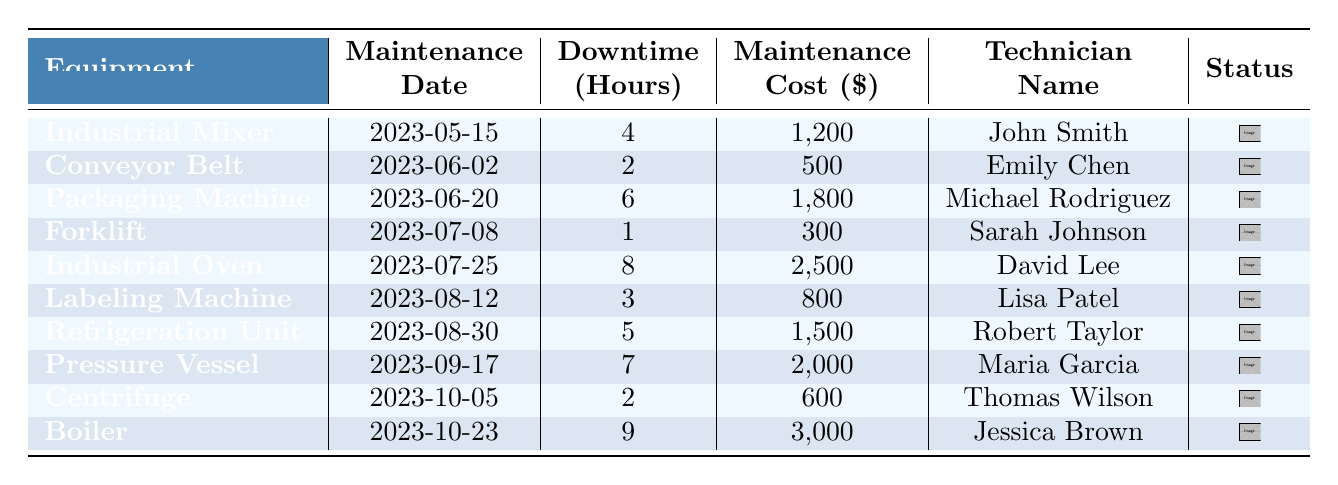What's the total downtime hours for all equipment? To find the total downtime hours, we sum the downtime for all equipment: 4 + 2 + 6 + 1 + 8 + 3 + 5 + 7 + 2 + 9 = 47 hours.
Answer: 47 Which piece of equipment had the highest maintenance cost? The maintenance costs for each piece of equipment are compared, and the highest cost is $3,000 for the Boiler.
Answer: Boiler What is the average downtime in hours per maintenance? The total downtime hours is 47 and there are 10 maintenance records. To find the average, divide 47 by 10: 47 / 10 = 4.7 hours.
Answer: 4.7 Did the Conveyor Belt have more downtime than the Labeling Machine? The Conveyor Belt had 2 hours of downtime and the Labeling Machine had 3 hours. Since 2 is less than 3, this statement is false.
Answer: No How many technicians had maintenance costs less than $1,500? We analyze the maintenance costs and find that the technicians associated with costs below $1,500 are Emily Chen ($500), Sarah Johnson ($300), Lisa Patel ($800), and Thomas Wilson ($600). This totals 4 technicians.
Answer: 4 What is the difference in downtime hours between the Industrial Oven and the Forklift? The Industrial Oven had 8 hours of downtime while the Forklift had 1 hour. The difference is 8 - 1 = 7 hours.
Answer: 7 Which technician performed maintenance on the Industrial Mixer? The table shows that John Smith was the technician who performed maintenance on the Industrial Mixer.
Answer: John Smith List all pieces of equipment that had a downtime of more than 5 hours. By examining the downtime hours, the pieces of equipment with more than 5 hours are the Packaging Machine (6), Industrial Oven (8), Refrigeration Unit (5), Pressure Vessel (7), and Boiler (9).
Answer: Packaging Machine, Industrial Oven, Pressure Vessel, Boiler If we add up the maintenance costs for all equipment, what is the total? Adding the maintenance costs together gives: 1200 + 500 + 1800 + 300 + 2500 + 800 + 1500 + 2000 + 600 + 3000 = 12,700 dollars.
Answer: 12,700 What equipment was maintained on the date 2023-08-30? The table indicates that on 2023-08-30, the Refrigeration Unit was maintained.
Answer: Refrigeration Unit 